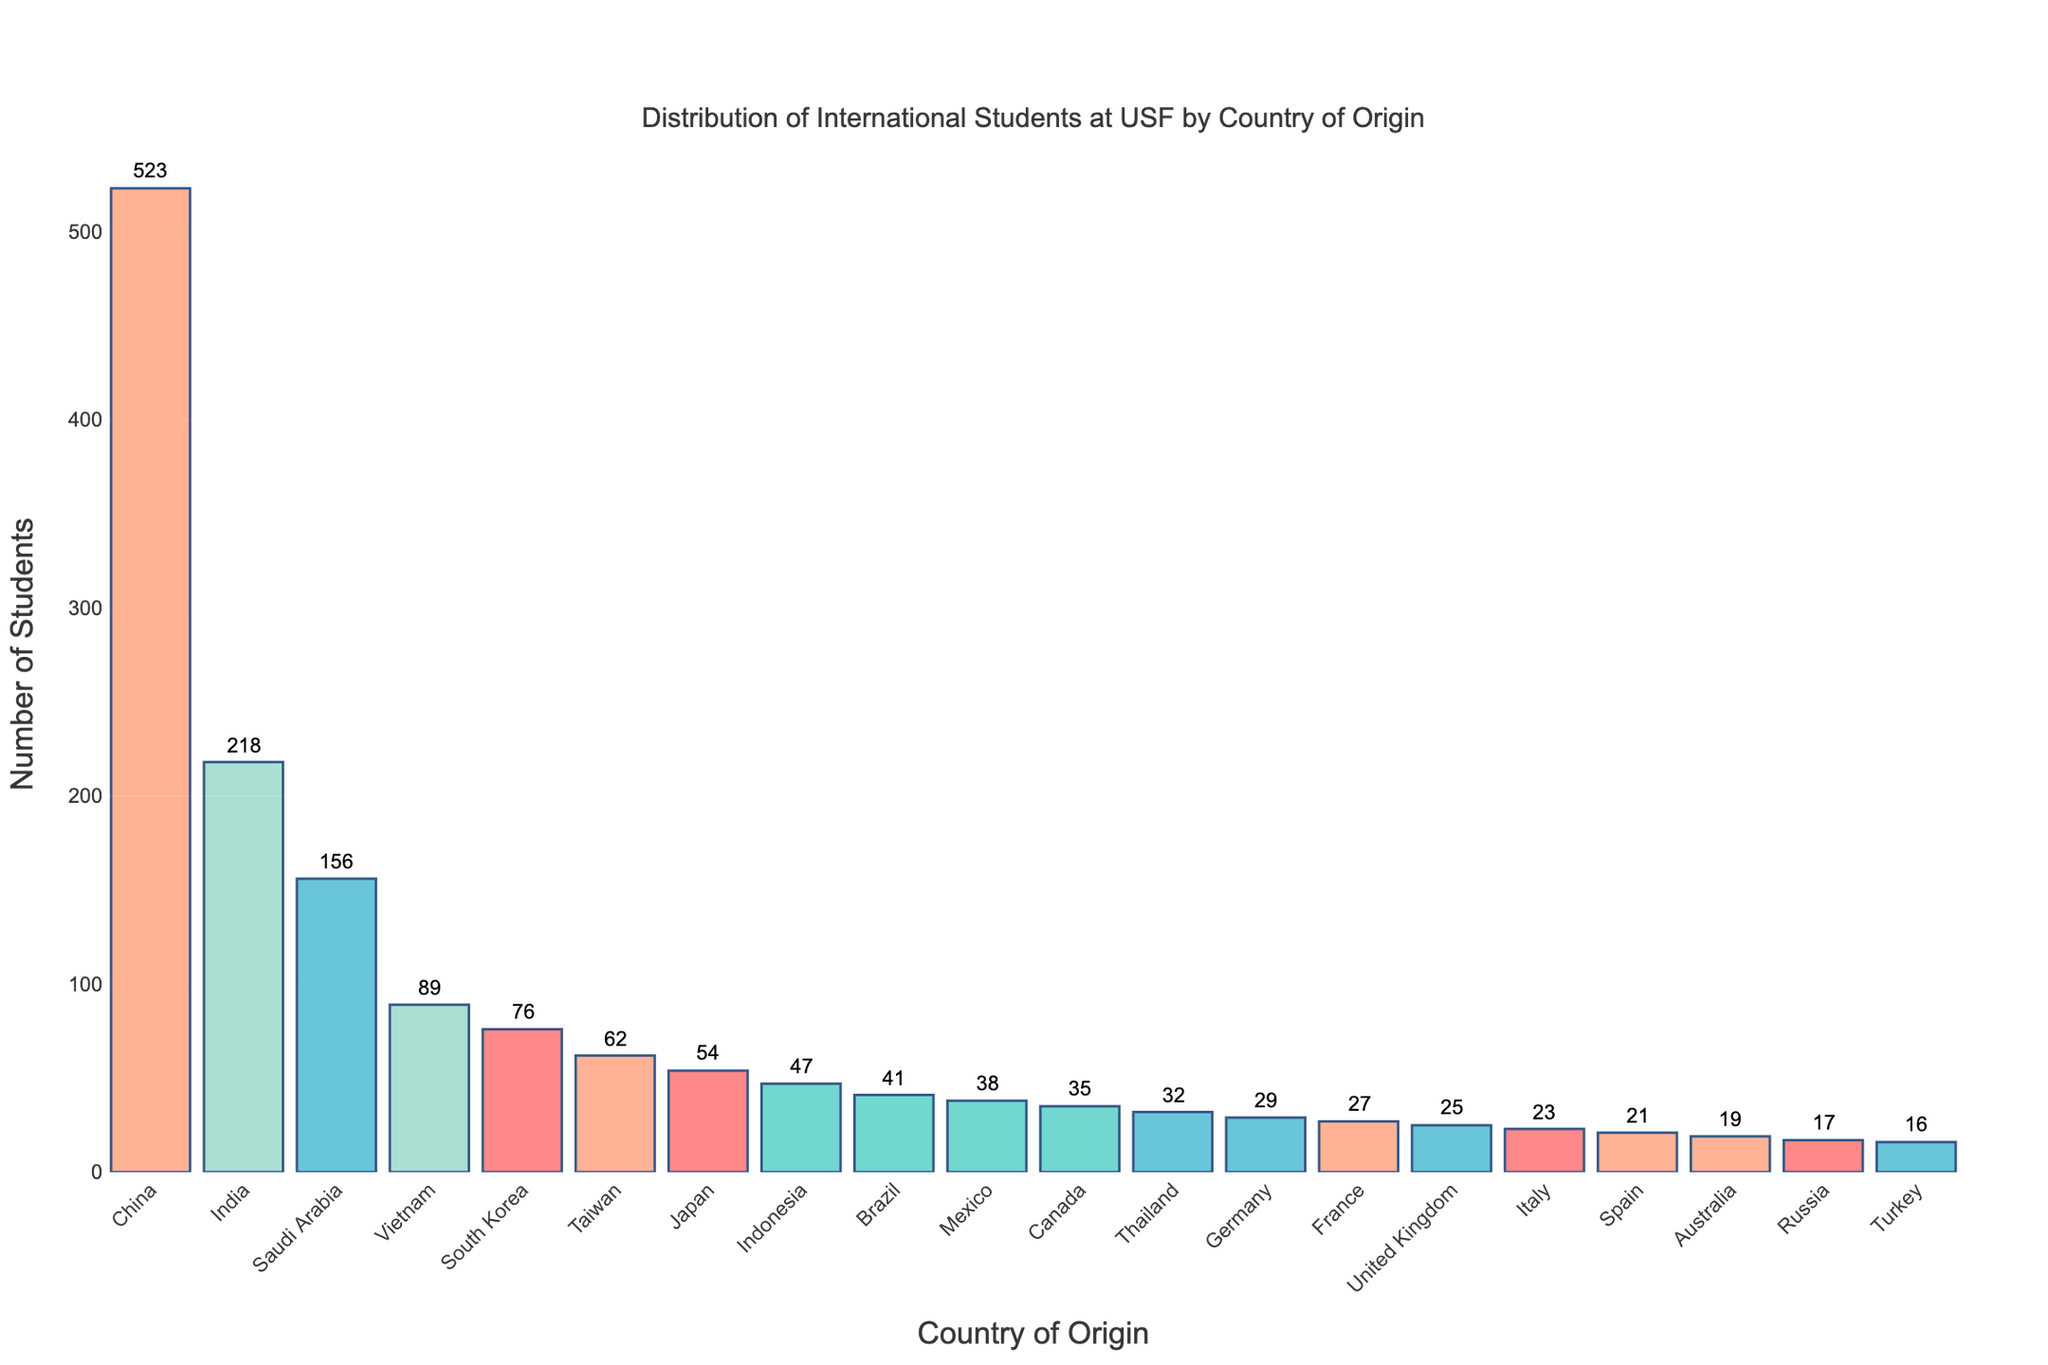What's the total number of international students from the top three countries? The top three countries by number of students are China (523), India (218), and Saudi Arabia (156). The total is 523 + 218 + 156 = 897.
Answer: 897 Which country has the lowest number of international students? By observing the heights of the bars, Turkey has the shortest bar representing 16 students.
Answer: Turkey How many more students are there from China compared to Mexico? China has 523 students, and Mexico has 38 students. The difference is 523 - 38 = 485.
Answer: 485 Is the number of students from Vietnam more than double the number of students from Canada? Vietnam has 89 students, and Canada has 35 students. Double the number of Canadian students is 35 * 2 = 70. Since 89 > 70, the number of students from Vietnam is more than double.
Answer: Yes Which country has a bar roughly half the height of Brazil's bar? Brazil has 41 students. Half of 41 is approximately 20.5. Russia, with 17 students, and Spain, with 21 students, have bars near this height.
Answer: Spain or Russia What is the average number of students from the countries listed? Add up all the students from each country (523 + 218 + 156 + 89 + ... + 16) = 1567. There are 20 countries, so the average is 1567 / 20 = 78.35.
Answer: 78.35 Which countries have bars with a similar height? Observing the bar heights, France (27 students) and United Kingdom (25 students) have similar bar heights.
Answer: France and United Kingdom Are there more students from Japan or Taiwan? By comparing the heights of the bars, Japan has 54 students, whereas Taiwan has 62 students. Taiwan has more students.
Answer: Taiwan How many countries have more than 100 students? By examining the bars, China, India, and Saudi Arabia have more than 100 students. That makes three countries in total.
Answer: 3 What is the combined total of students from Indonesia, Brazil, and Mexico? Indonesia has 47 students, Brazil has 41, and Mexico has 38. Their combined total is 47 + 41 + 38 = 126.
Answer: 126 